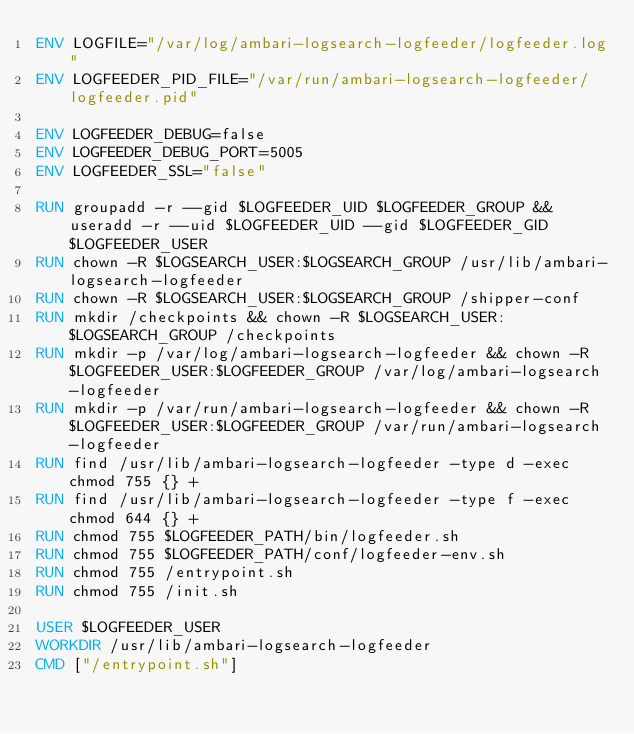<code> <loc_0><loc_0><loc_500><loc_500><_Dockerfile_>ENV LOGFILE="/var/log/ambari-logsearch-logfeeder/logfeeder.log"
ENV LOGFEEDER_PID_FILE="/var/run/ambari-logsearch-logfeeder/logfeeder.pid"

ENV LOGFEEDER_DEBUG=false
ENV LOGFEEDER_DEBUG_PORT=5005
ENV LOGFEEDER_SSL="false"

RUN groupadd -r --gid $LOGFEEDER_UID $LOGFEEDER_GROUP && useradd -r --uid $LOGFEEDER_UID --gid $LOGFEEDER_GID $LOGFEEDER_USER
RUN chown -R $LOGSEARCH_USER:$LOGSEARCH_GROUP /usr/lib/ambari-logsearch-logfeeder
RUN chown -R $LOGSEARCH_USER:$LOGSEARCH_GROUP /shipper-conf
RUN mkdir /checkpoints && chown -R $LOGSEARCH_USER:$LOGSEARCH_GROUP /checkpoints
RUN mkdir -p /var/log/ambari-logsearch-logfeeder && chown -R $LOGFEEDER_USER:$LOGFEEDER_GROUP /var/log/ambari-logsearch-logfeeder
RUN mkdir -p /var/run/ambari-logsearch-logfeeder && chown -R $LOGFEEDER_USER:$LOGFEEDER_GROUP /var/run/ambari-logsearch-logfeeder
RUN find /usr/lib/ambari-logsearch-logfeeder -type d -exec chmod 755 {} +
RUN find /usr/lib/ambari-logsearch-logfeeder -type f -exec chmod 644 {} +
RUN chmod 755 $LOGFEEDER_PATH/bin/logfeeder.sh
RUN chmod 755 $LOGFEEDER_PATH/conf/logfeeder-env.sh
RUN chmod 755 /entrypoint.sh
RUN chmod 755 /init.sh

USER $LOGFEEDER_USER
WORKDIR /usr/lib/ambari-logsearch-logfeeder
CMD ["/entrypoint.sh"]</code> 